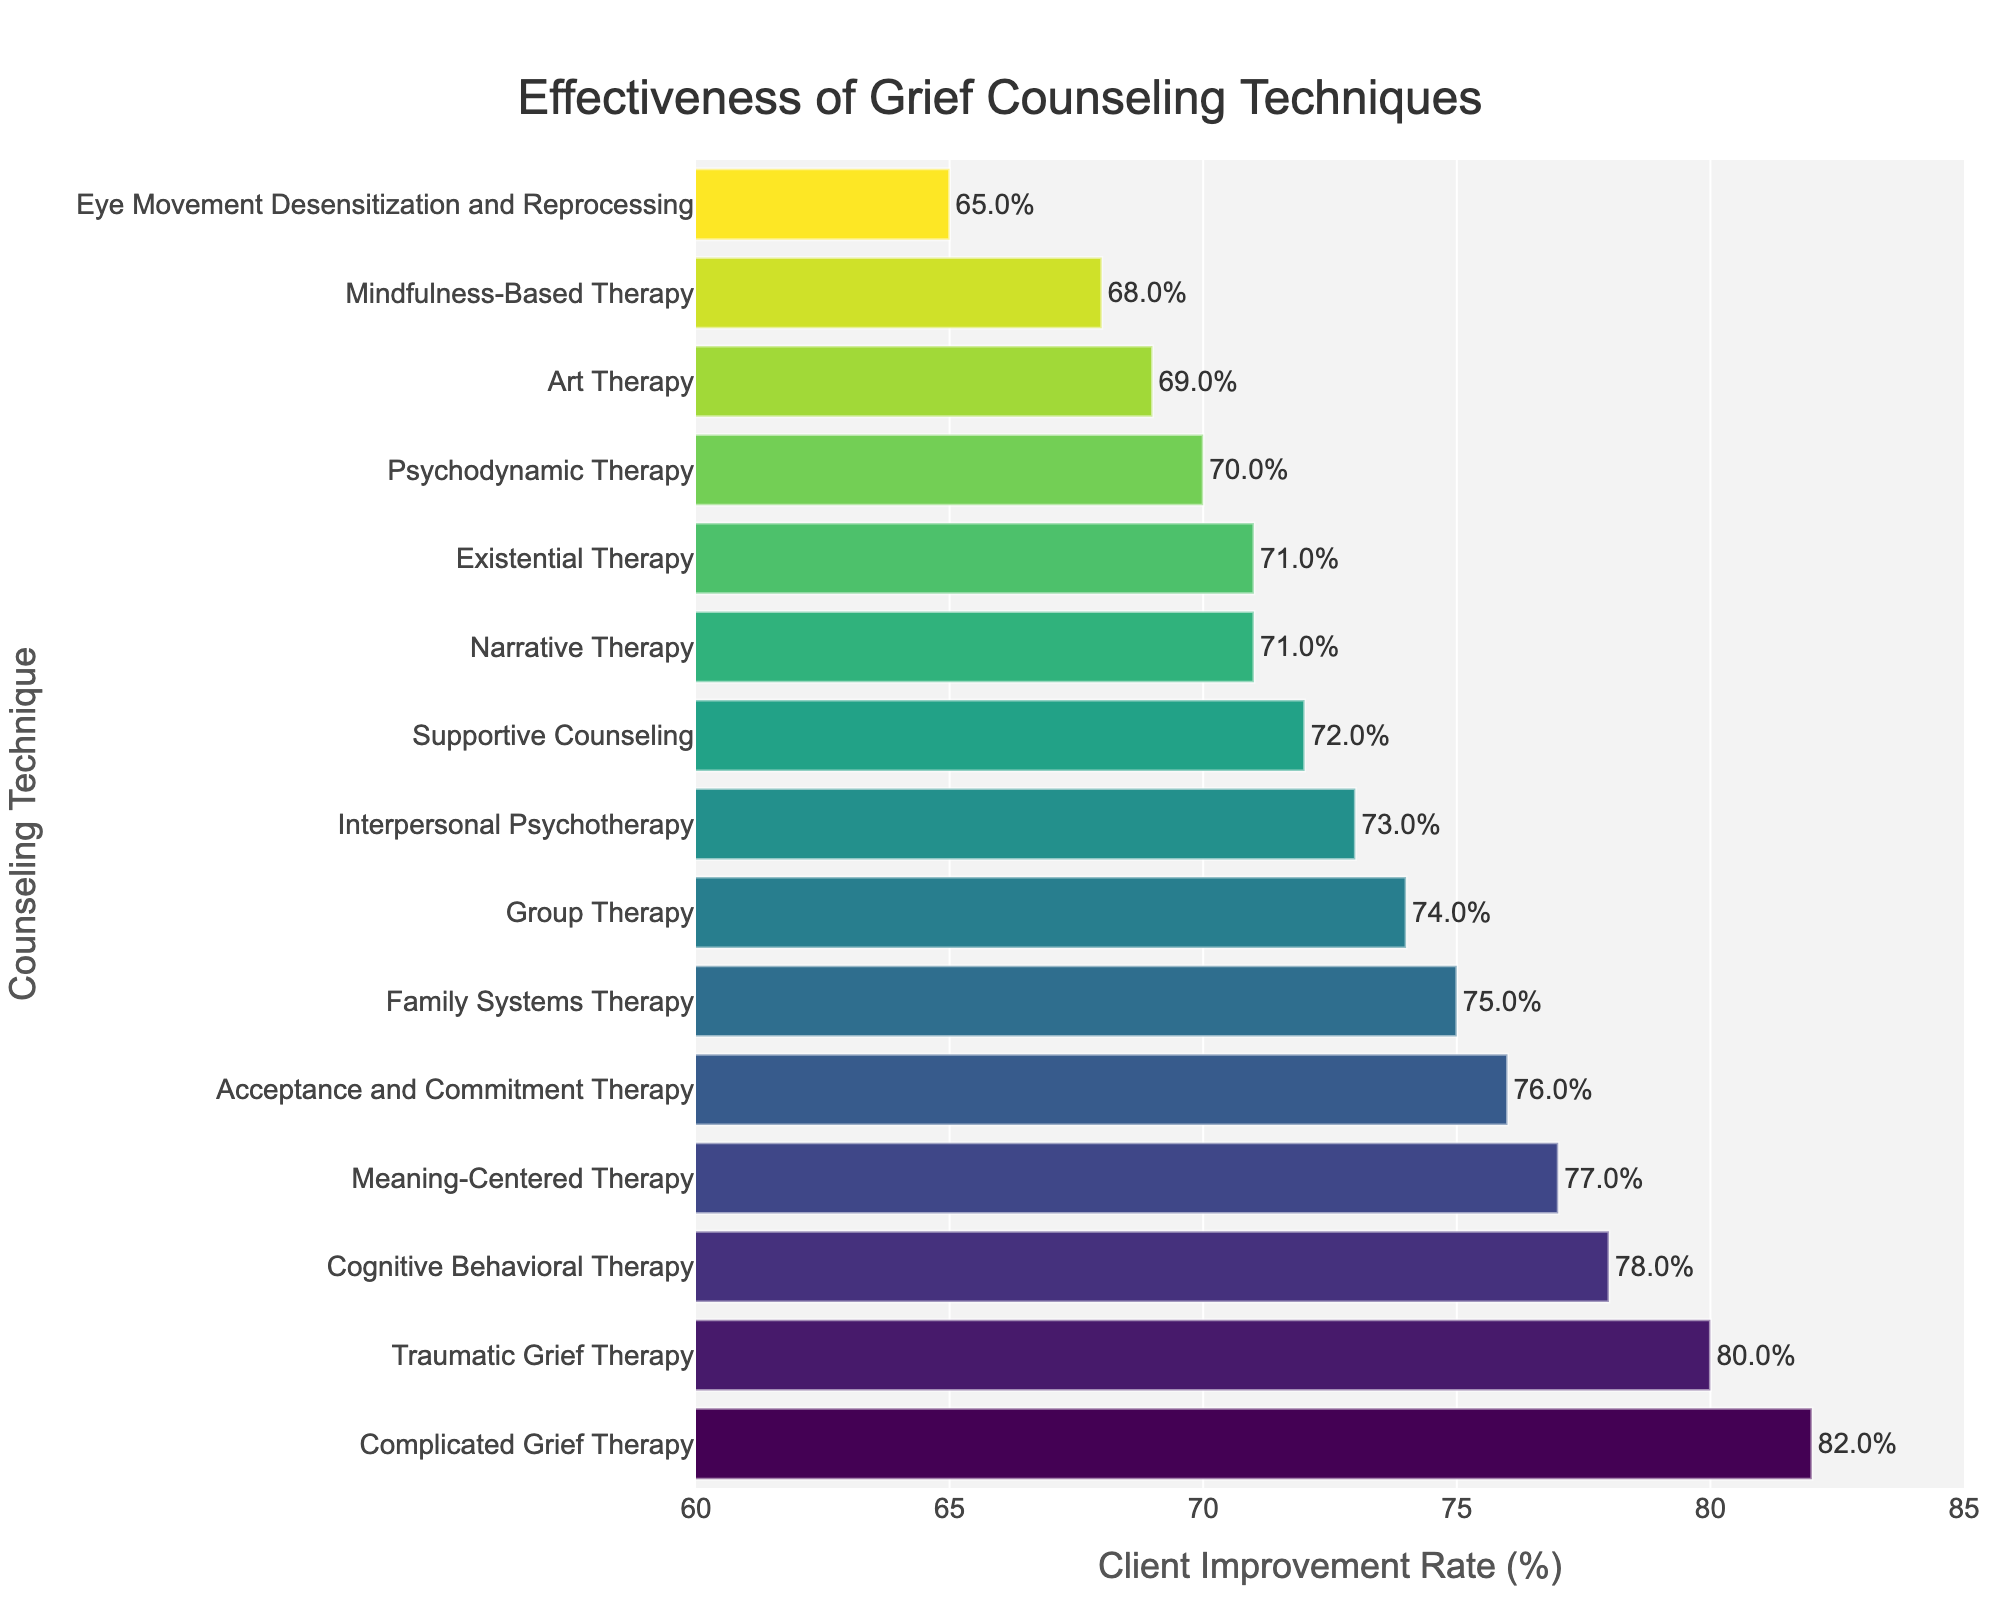Which technique has the highest improvement rate? The technique with the highest improvement rate can be identified by looking at the bar with the greatest length towards the right on the horizontal bar chart. Complicated Grief Therapy has the longest bar.
Answer: Complicated Grief Therapy What is the improvement rate of Traumatic Grief Therapy? To find the improvement rate, locate the Traumatic Grief Therapy on the vertical axis and see where its corresponding bar ends on the horizontal axis. Traumatic Grief Therapy has a value of 80%.
Answer: 80% How does the improvement rate of Cognitive Behavioral Therapy compare to that of Mindfulness-Based Therapy? Compare the length of the bars for Cognitive Behavioral Therapy and Mindfulness-Based Therapy. The former is longer, indicating a higher improvement rate of 78% compared to Mindfulness-Based Therapy's 68%.
Answer: Cognitive Behavioral Therapy has a higher improvement rate Which technique shows just below average? First, you need to find the average improvement rate across all techniques. It requires summing up all rates and dividing by the number of techniques, then identify the bar closest to but below this value. Average = (65+68+69+70+71+71+72+73+74+75+76+77+78+80+82)/15 = 73.333%. Narrative Therapy has an improvement rate of 71%, which is closest to but below the average.
Answer: Narrative Therapy What is the difference in improvement rates between Group Therapy and Art Therapy? Identify the rates for both techniques and subtract the smaller from the larger. Group Therapy has 74% and Art Therapy has 69%, so the difference is 74% - 69% = 5%.
Answer: 5% Are there more techniques with improvement rates greater than 75% or less than 75%? Count the number of bars above 75% and those below 75%. Techniques greater than 75%: 6. Techniques less than 75%: 9.
Answer: Less than 75% Which technique is the least effective? The least effective technique will have the shortest bar on the horizontal bar chart. Eye Movement Desensitization and Reprocessing has the shortest bar at 65%.
Answer: Eye Movement Desensitization and Reprocessing What is the median improvement rate of all techniques? To find the median, list all improvement rates in ascending order and find the middle value. Ordered rates: [65, 68, 69, 70, 71, 71, 72, 73, 74, 75, 76, 77, 78, 80, 82]. The median is the middle value, which is 73%.
Answer: 73% Is Meaning-Centered Therapy more effective than Family Systems Therapy? Compare the lengths of the bars; Meaning-Centered Therapy is longer and has an improvement rate of 77%, while Family Systems Therapy has 75%. Therefore, Meaning-Centered Therapy is more effective.
Answer: Yes 